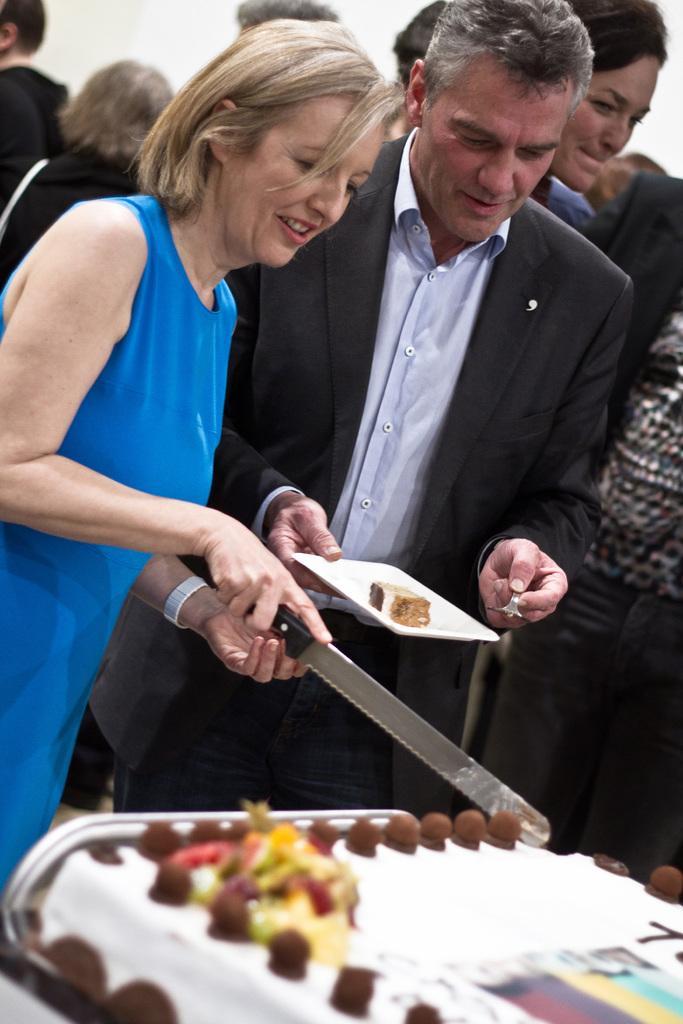In one or two sentences, can you explain what this image depicts? In this picture we can see a women with a blue dress is cutting a cake and beside to her there is one man by holding a plate in which we can see a cake and this is a fork in his hand. Behind to them there are few persons standing. 